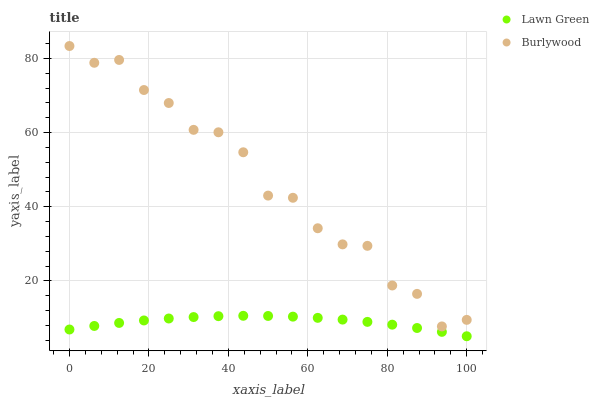Does Lawn Green have the minimum area under the curve?
Answer yes or no. Yes. Does Burlywood have the maximum area under the curve?
Answer yes or no. Yes. Does Lawn Green have the maximum area under the curve?
Answer yes or no. No. Is Lawn Green the smoothest?
Answer yes or no. Yes. Is Burlywood the roughest?
Answer yes or no. Yes. Is Lawn Green the roughest?
Answer yes or no. No. Does Lawn Green have the lowest value?
Answer yes or no. Yes. Does Burlywood have the highest value?
Answer yes or no. Yes. Does Lawn Green have the highest value?
Answer yes or no. No. Is Lawn Green less than Burlywood?
Answer yes or no. Yes. Is Burlywood greater than Lawn Green?
Answer yes or no. Yes. Does Lawn Green intersect Burlywood?
Answer yes or no. No. 